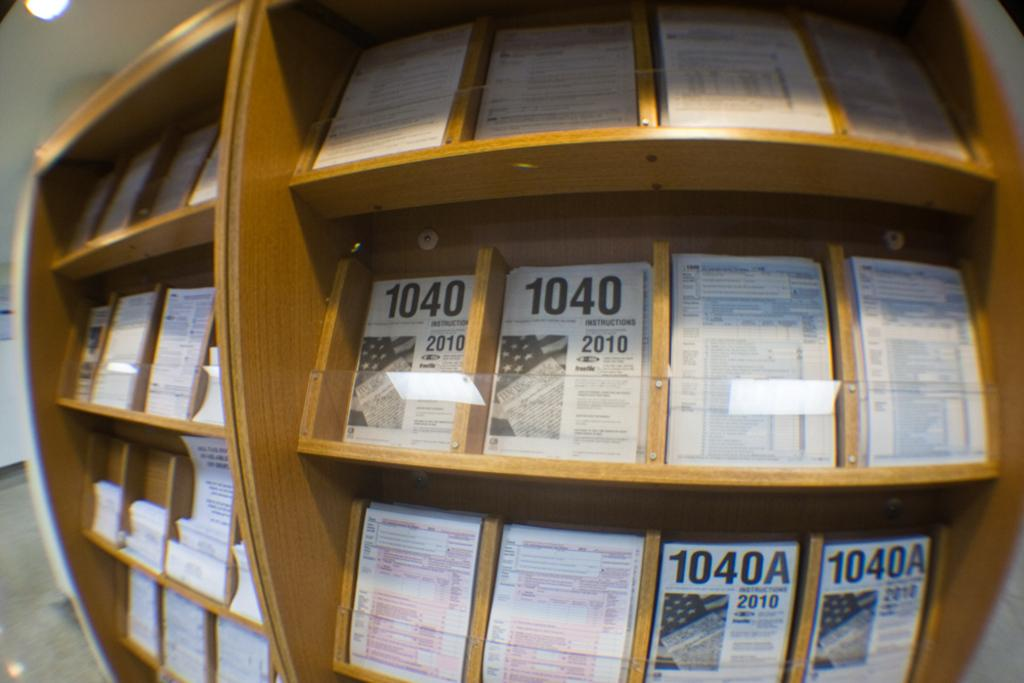Provide a one-sentence caption for the provided image. Shelf full of different framed papers including one from 2010. 